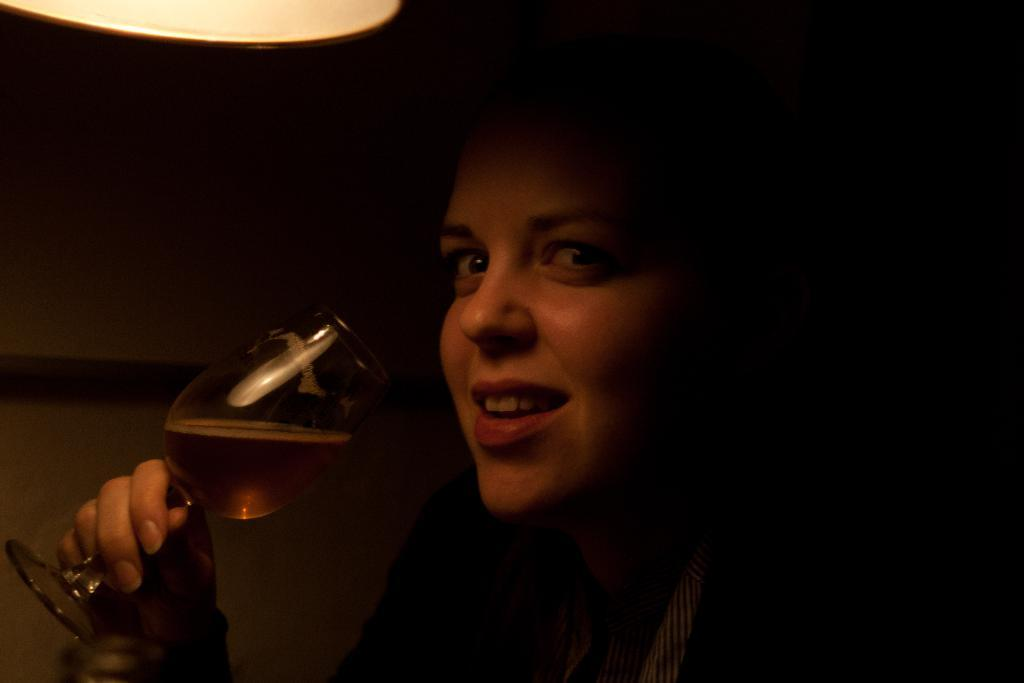Who is the main subject in the image? There is a woman in the image. What is the woman holding in the image? The woman is holding a glass. What is the woman's facial expression in the image? The woman is smiling. What can be seen in the image that provides light? There is a light visible in the image. How would you describe the overall lighting in the image? The background of the image appears dark. What type of eggnog is the woman drinking in the image? There is no eggnog present in the image; the woman is holding a glass, but its contents are not specified. 